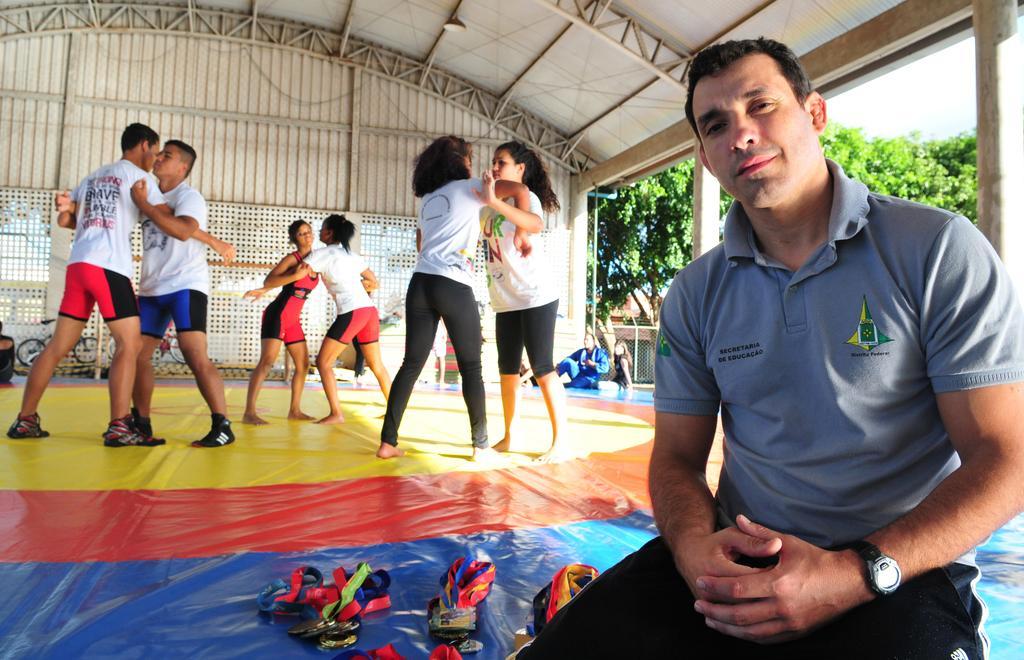Describe this image in one or two sentences. Here in this picture in the front we can see a person sitting on the floor over there and beside him we can see number of medals present over there and behind him we can see groups of people training for martial arts and at the top we can see a shed present and we can also see bicycles in the far and on the right side we can see number of trees present over there. 